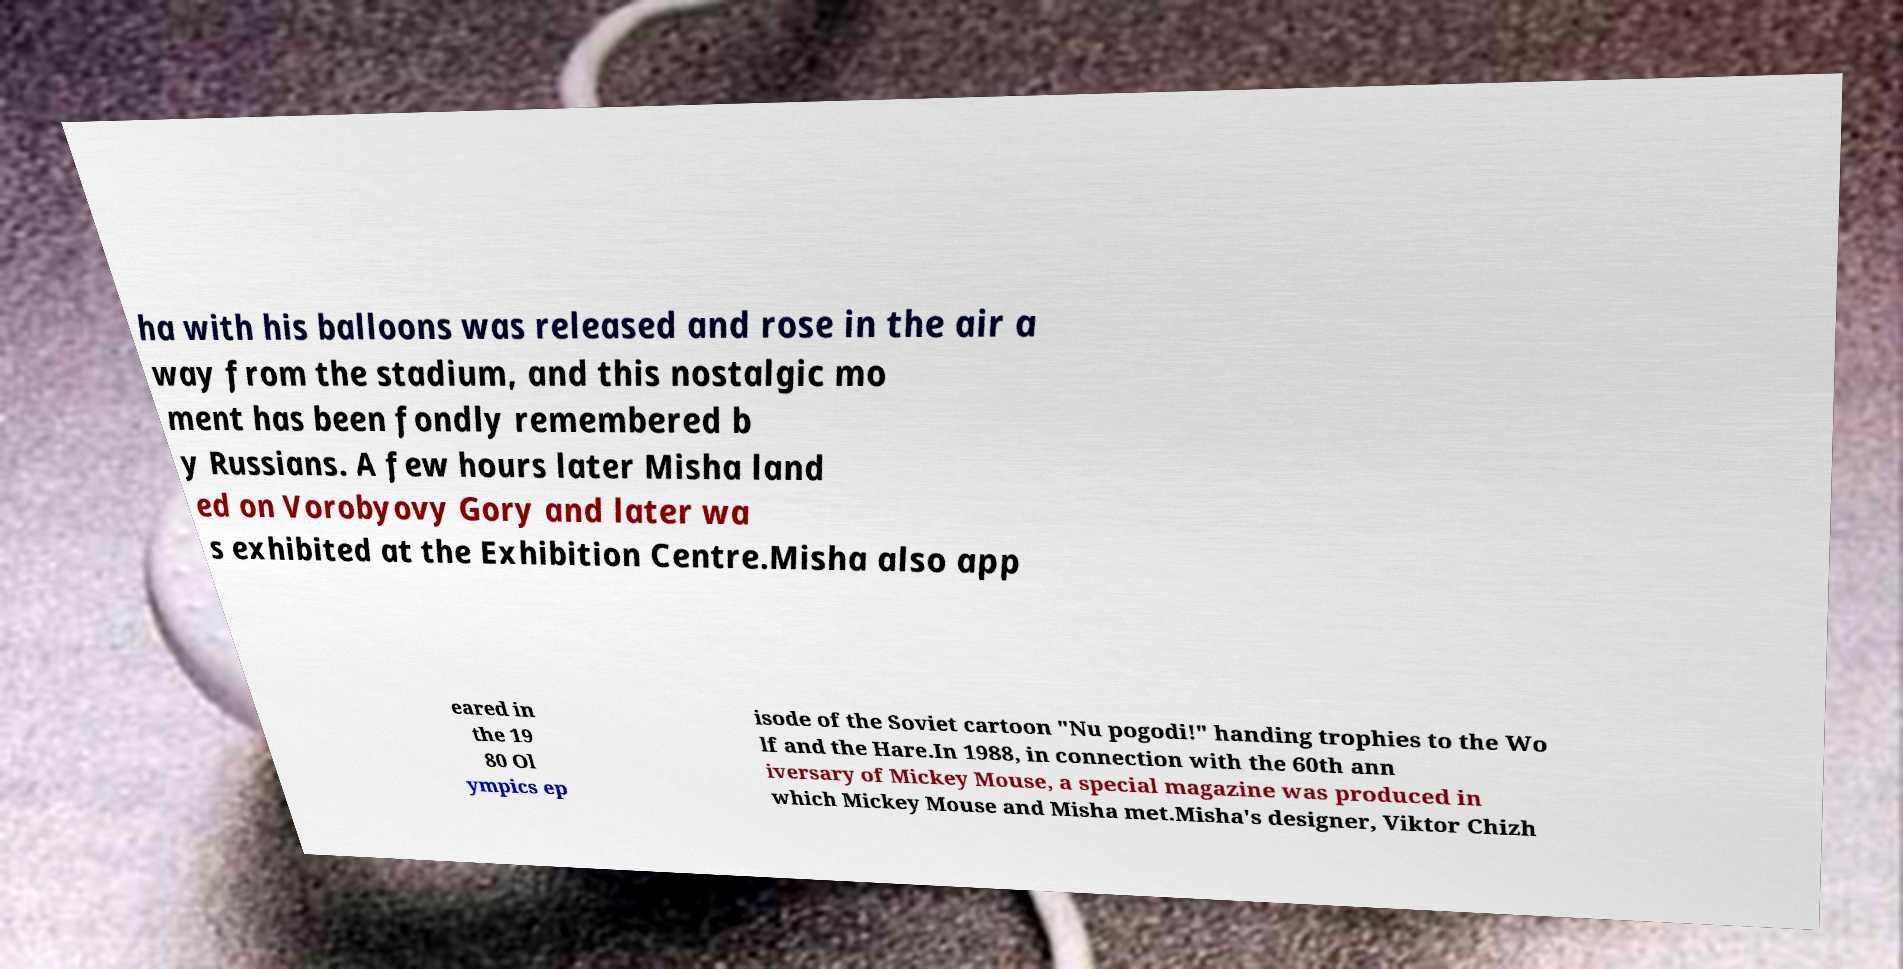Please identify and transcribe the text found in this image. ha with his balloons was released and rose in the air a way from the stadium, and this nostalgic mo ment has been fondly remembered b y Russians. A few hours later Misha land ed on Vorobyovy Gory and later wa s exhibited at the Exhibition Centre.Misha also app eared in the 19 80 Ol ympics ep isode of the Soviet cartoon "Nu pogodi!" handing trophies to the Wo lf and the Hare.In 1988, in connection with the 60th ann iversary of Mickey Mouse, a special magazine was produced in which Mickey Mouse and Misha met.Misha's designer, Viktor Chizh 